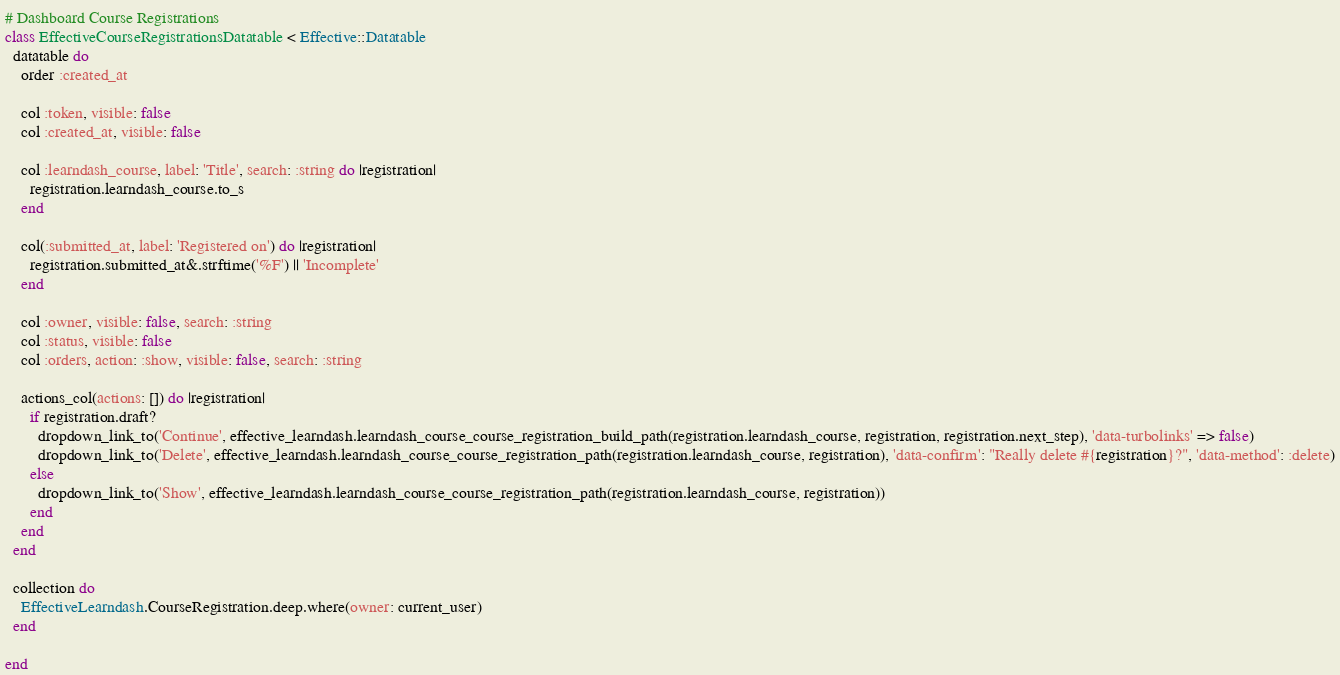<code> <loc_0><loc_0><loc_500><loc_500><_Ruby_># Dashboard Course Registrations
class EffectiveCourseRegistrationsDatatable < Effective::Datatable
  datatable do
    order :created_at

    col :token, visible: false
    col :created_at, visible: false

    col :learndash_course, label: 'Title', search: :string do |registration|
      registration.learndash_course.to_s
    end

    col(:submitted_at, label: 'Registered on') do |registration|
      registration.submitted_at&.strftime('%F') || 'Incomplete'
    end

    col :owner, visible: false, search: :string
    col :status, visible: false
    col :orders, action: :show, visible: false, search: :string

    actions_col(actions: []) do |registration|
      if registration.draft?
        dropdown_link_to('Continue', effective_learndash.learndash_course_course_registration_build_path(registration.learndash_course, registration, registration.next_step), 'data-turbolinks' => false)
        dropdown_link_to('Delete', effective_learndash.learndash_course_course_registration_path(registration.learndash_course, registration), 'data-confirm': "Really delete #{registration}?", 'data-method': :delete)
      else
        dropdown_link_to('Show', effective_learndash.learndash_course_course_registration_path(registration.learndash_course, registration))
      end
    end
  end

  collection do
    EffectiveLearndash.CourseRegistration.deep.where(owner: current_user)
  end

end
</code> 